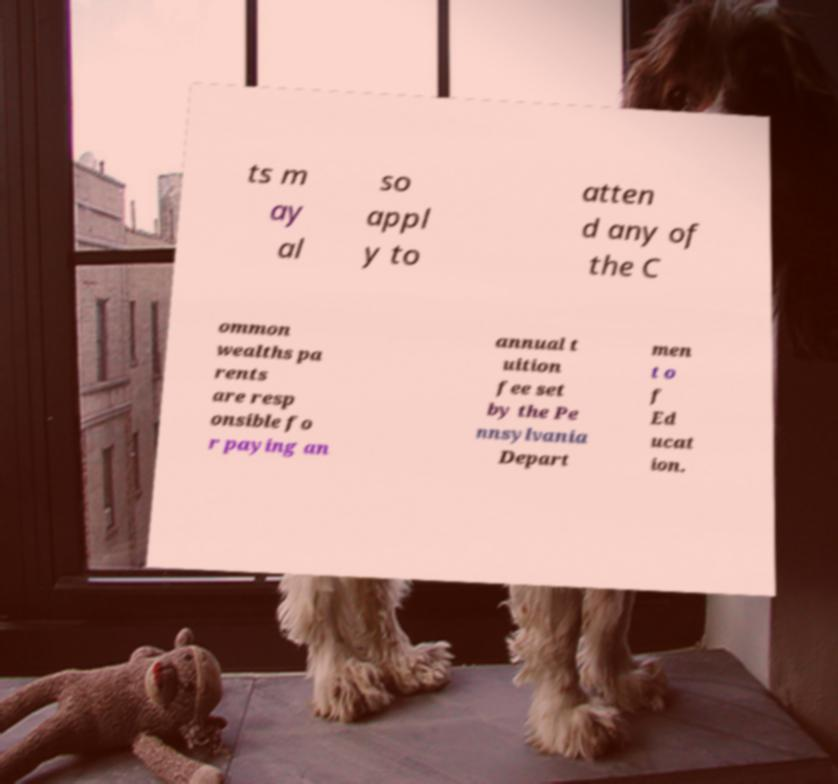For documentation purposes, I need the text within this image transcribed. Could you provide that? ts m ay al so appl y to atten d any of the C ommon wealths pa rents are resp onsible fo r paying an annual t uition fee set by the Pe nnsylvania Depart men t o f Ed ucat ion. 